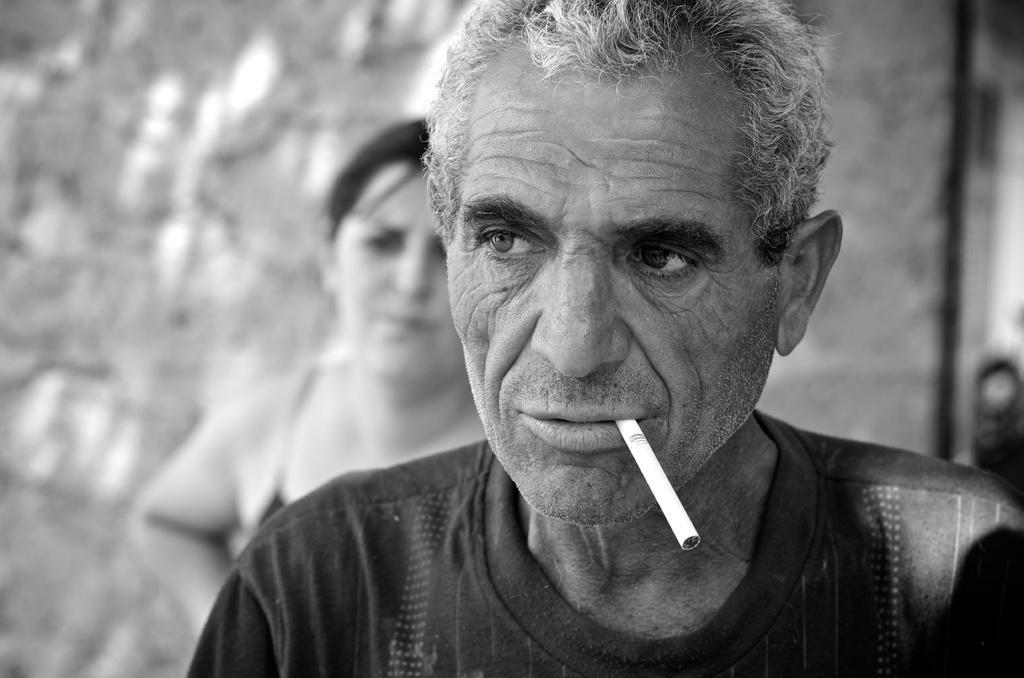Please provide a concise description of this image. This picture shows a man and a woman on the back and we see a man wore a black t-shirt and a cigarette in his mouth. 